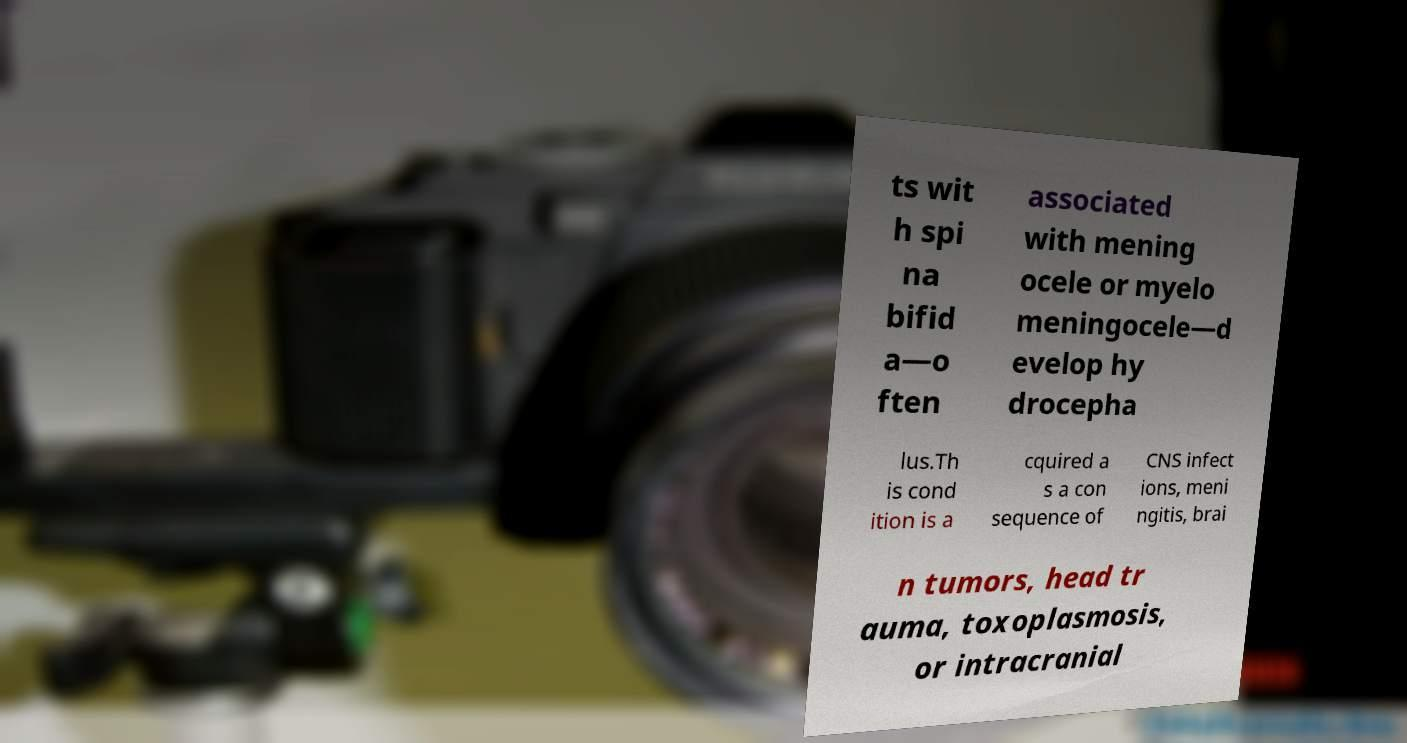Could you assist in decoding the text presented in this image and type it out clearly? ts wit h spi na bifid a—o ften associated with mening ocele or myelo meningocele—d evelop hy drocepha lus.Th is cond ition is a cquired a s a con sequence of CNS infect ions, meni ngitis, brai n tumors, head tr auma, toxoplasmosis, or intracranial 